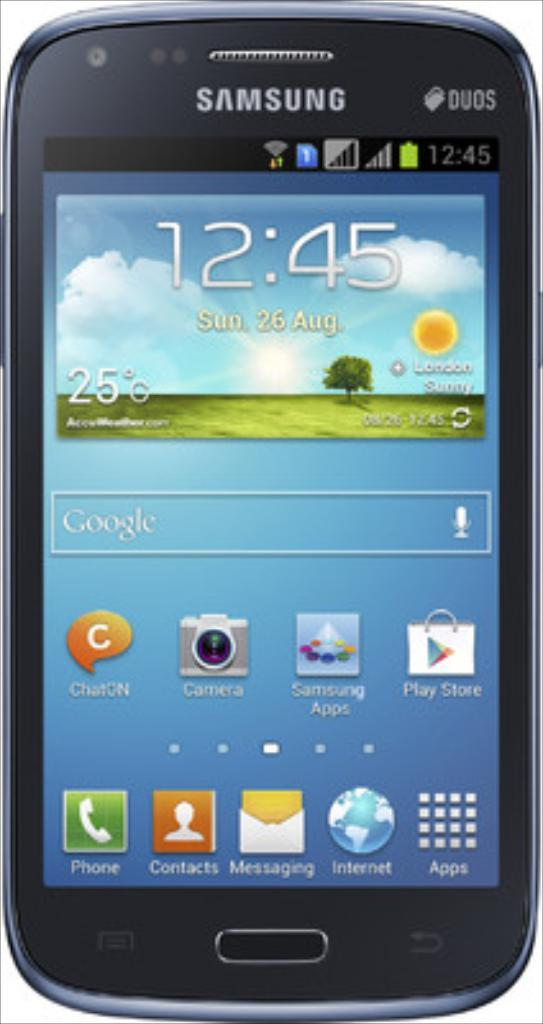Provide a one-sentence caption for the provided image. A Samsung mobile device at 12:45 on August 26. 